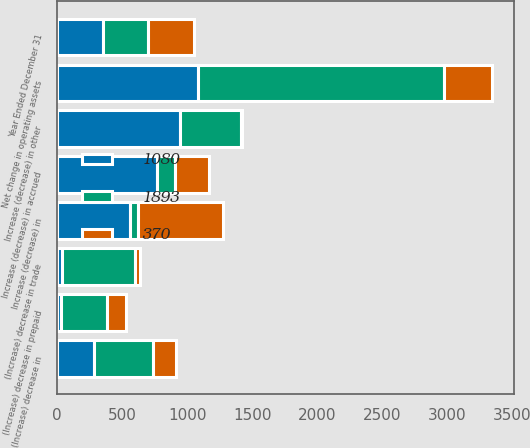Convert chart. <chart><loc_0><loc_0><loc_500><loc_500><stacked_bar_chart><ecel><fcel>Year Ended December 31<fcel>(Increase) decrease in trade<fcel>(Increase) decrease in<fcel>(Increase) decrease in prepaid<fcel>Increase (decrease) in<fcel>Increase (decrease) in accrued<fcel>Increase (decrease) in other<fcel>Net change in operating assets<nl><fcel>1080<fcel>350<fcel>33<fcel>286<fcel>29<fcel>556<fcel>770<fcel>946<fcel>1080<nl><fcel>1893<fcel>350<fcel>562<fcel>447<fcel>350<fcel>63<fcel>132<fcel>465<fcel>1893<nl><fcel>370<fcel>350<fcel>41<fcel>182<fcel>148<fcel>656<fcel>266<fcel>13<fcel>370<nl></chart> 